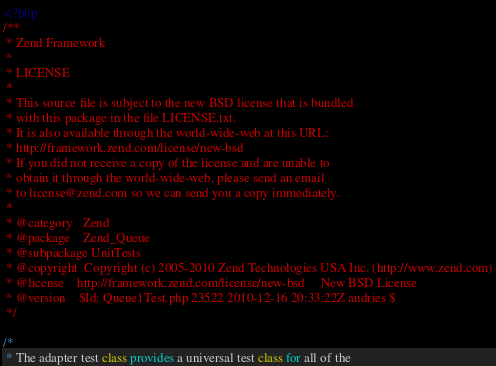Convert code to text. <code><loc_0><loc_0><loc_500><loc_500><_PHP_><?php
/**
 * Zend Framework
 *
 * LICENSE
 *
 * This source file is subject to the new BSD license that is bundled
 * with this package in the file LICENSE.txt.
 * It is also available through the world-wide-web at this URL:
 * http://framework.zend.com/license/new-bsd
 * If you did not receive a copy of the license and are unable to
 * obtain it through the world-wide-web, please send an email
 * to license@zend.com so we can send you a copy immediately.
 *
 * @category   Zend
 * @package    Zend_Queue
 * @subpackage UnitTests
 * @copyright  Copyright (c) 2005-2010 Zend Technologies USA Inc. (http://www.zend.com)
 * @license    http://framework.zend.com/license/new-bsd     New BSD License
 * @version    $Id: Queue1Test.php 23522 2010-12-16 20:33:22Z andries $
 */

/*
 * The adapter test class provides a universal test class for all of the</code> 